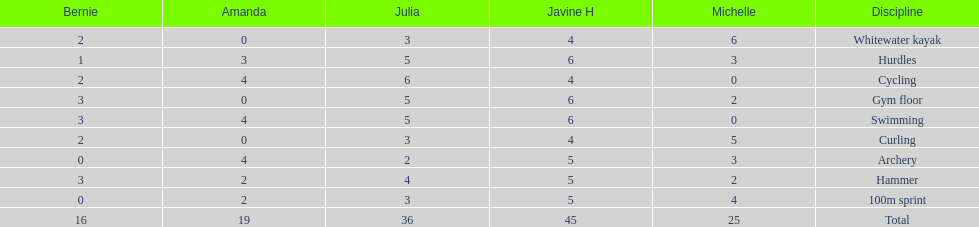What is the average score on 100m sprint? 2.8. 